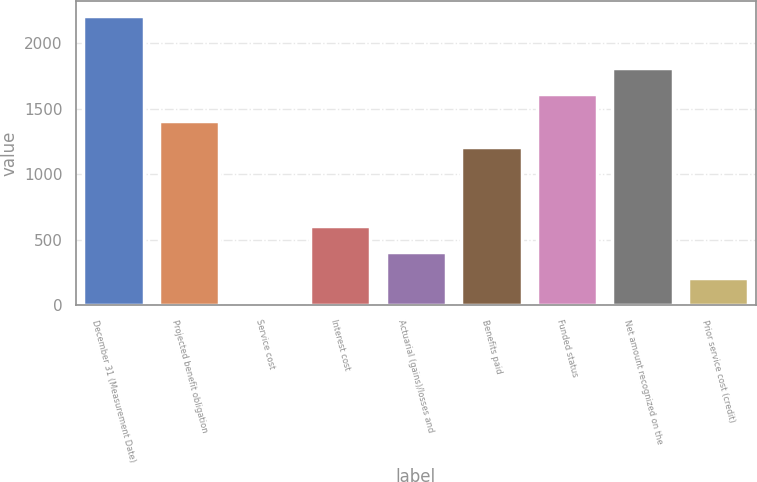<chart> <loc_0><loc_0><loc_500><loc_500><bar_chart><fcel>December 31 (Measurement Date)<fcel>Projected benefit obligation<fcel>Service cost<fcel>Interest cost<fcel>Actuarial (gains)/losses and<fcel>Benefits paid<fcel>Funded status<fcel>Net amount recognized on the<fcel>Prior service cost (credit)<nl><fcel>2213.7<fcel>1410.9<fcel>6<fcel>608.1<fcel>407.4<fcel>1210.2<fcel>1611.6<fcel>1812.3<fcel>206.7<nl></chart> 